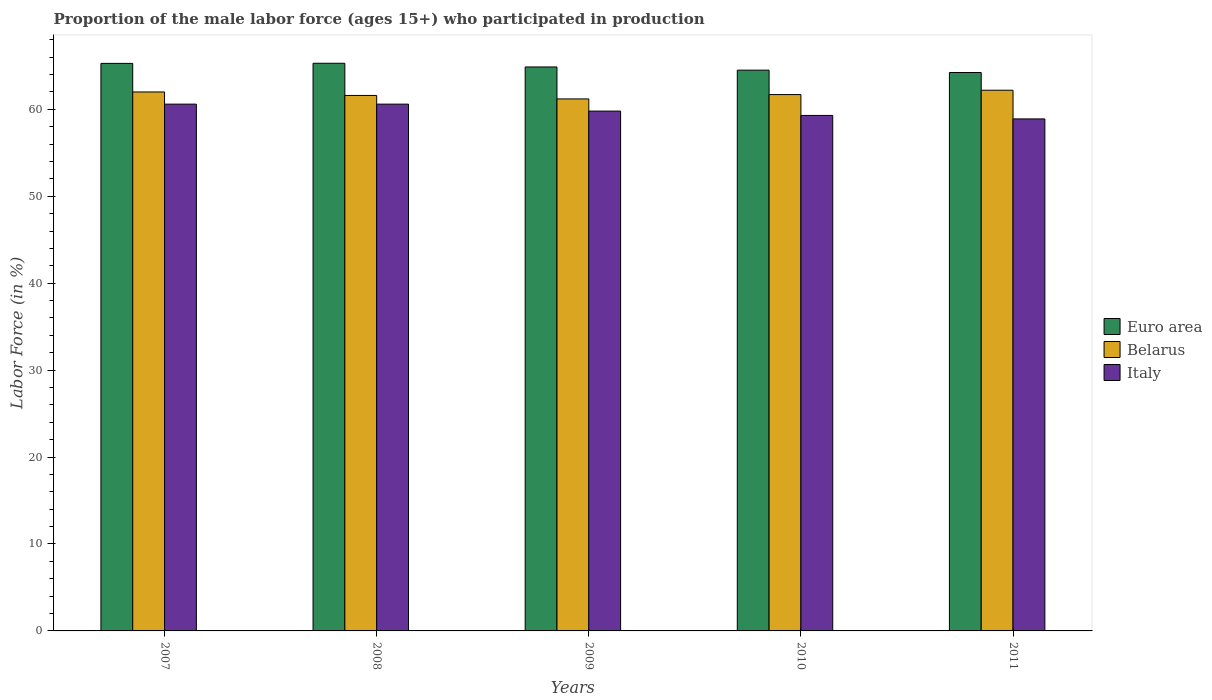How many different coloured bars are there?
Your response must be concise. 3. How many groups of bars are there?
Provide a succinct answer. 5. Are the number of bars per tick equal to the number of legend labels?
Keep it short and to the point. Yes. Are the number of bars on each tick of the X-axis equal?
Your answer should be very brief. Yes. How many bars are there on the 5th tick from the right?
Offer a very short reply. 3. What is the label of the 3rd group of bars from the left?
Provide a succinct answer. 2009. In how many cases, is the number of bars for a given year not equal to the number of legend labels?
Provide a short and direct response. 0. What is the proportion of the male labor force who participated in production in Euro area in 2011?
Offer a very short reply. 64.24. Across all years, what is the maximum proportion of the male labor force who participated in production in Euro area?
Provide a short and direct response. 65.3. Across all years, what is the minimum proportion of the male labor force who participated in production in Belarus?
Your answer should be compact. 61.2. In which year was the proportion of the male labor force who participated in production in Belarus minimum?
Make the answer very short. 2009. What is the total proportion of the male labor force who participated in production in Italy in the graph?
Offer a very short reply. 299.2. What is the difference between the proportion of the male labor force who participated in production in Italy in 2007 and that in 2009?
Keep it short and to the point. 0.8. What is the difference between the proportion of the male labor force who participated in production in Belarus in 2007 and the proportion of the male labor force who participated in production in Euro area in 2011?
Offer a very short reply. -2.24. What is the average proportion of the male labor force who participated in production in Belarus per year?
Your response must be concise. 61.74. In the year 2008, what is the difference between the proportion of the male labor force who participated in production in Euro area and proportion of the male labor force who participated in production in Belarus?
Offer a terse response. 3.7. In how many years, is the proportion of the male labor force who participated in production in Euro area greater than 58 %?
Provide a succinct answer. 5. What is the ratio of the proportion of the male labor force who participated in production in Euro area in 2008 to that in 2010?
Your response must be concise. 1.01. Is the proportion of the male labor force who participated in production in Belarus in 2009 less than that in 2011?
Provide a succinct answer. Yes. Is the difference between the proportion of the male labor force who participated in production in Euro area in 2008 and 2010 greater than the difference between the proportion of the male labor force who participated in production in Belarus in 2008 and 2010?
Give a very brief answer. Yes. What is the difference between the highest and the second highest proportion of the male labor force who participated in production in Euro area?
Offer a terse response. 0.01. In how many years, is the proportion of the male labor force who participated in production in Euro area greater than the average proportion of the male labor force who participated in production in Euro area taken over all years?
Offer a terse response. 3. Is the sum of the proportion of the male labor force who participated in production in Belarus in 2010 and 2011 greater than the maximum proportion of the male labor force who participated in production in Euro area across all years?
Offer a very short reply. Yes. What does the 1st bar from the right in 2007 represents?
Ensure brevity in your answer.  Italy. Is it the case that in every year, the sum of the proportion of the male labor force who participated in production in Italy and proportion of the male labor force who participated in production in Euro area is greater than the proportion of the male labor force who participated in production in Belarus?
Give a very brief answer. Yes. Are all the bars in the graph horizontal?
Your answer should be very brief. No. How many years are there in the graph?
Give a very brief answer. 5. What is the difference between two consecutive major ticks on the Y-axis?
Offer a very short reply. 10. Does the graph contain any zero values?
Your answer should be compact. No. How are the legend labels stacked?
Offer a very short reply. Vertical. What is the title of the graph?
Provide a short and direct response. Proportion of the male labor force (ages 15+) who participated in production. What is the Labor Force (in %) in Euro area in 2007?
Give a very brief answer. 65.29. What is the Labor Force (in %) of Belarus in 2007?
Ensure brevity in your answer.  62. What is the Labor Force (in %) in Italy in 2007?
Offer a very short reply. 60.6. What is the Labor Force (in %) in Euro area in 2008?
Your answer should be very brief. 65.3. What is the Labor Force (in %) of Belarus in 2008?
Give a very brief answer. 61.6. What is the Labor Force (in %) in Italy in 2008?
Your answer should be very brief. 60.6. What is the Labor Force (in %) of Euro area in 2009?
Provide a short and direct response. 64.88. What is the Labor Force (in %) of Belarus in 2009?
Your response must be concise. 61.2. What is the Labor Force (in %) of Italy in 2009?
Your answer should be very brief. 59.8. What is the Labor Force (in %) in Euro area in 2010?
Give a very brief answer. 64.51. What is the Labor Force (in %) in Belarus in 2010?
Offer a very short reply. 61.7. What is the Labor Force (in %) of Italy in 2010?
Provide a succinct answer. 59.3. What is the Labor Force (in %) in Euro area in 2011?
Ensure brevity in your answer.  64.24. What is the Labor Force (in %) in Belarus in 2011?
Offer a terse response. 62.2. What is the Labor Force (in %) of Italy in 2011?
Your response must be concise. 58.9. Across all years, what is the maximum Labor Force (in %) in Euro area?
Offer a terse response. 65.3. Across all years, what is the maximum Labor Force (in %) in Belarus?
Make the answer very short. 62.2. Across all years, what is the maximum Labor Force (in %) in Italy?
Keep it short and to the point. 60.6. Across all years, what is the minimum Labor Force (in %) in Euro area?
Provide a succinct answer. 64.24. Across all years, what is the minimum Labor Force (in %) in Belarus?
Keep it short and to the point. 61.2. Across all years, what is the minimum Labor Force (in %) of Italy?
Offer a very short reply. 58.9. What is the total Labor Force (in %) of Euro area in the graph?
Your answer should be compact. 324.22. What is the total Labor Force (in %) in Belarus in the graph?
Your answer should be very brief. 308.7. What is the total Labor Force (in %) in Italy in the graph?
Provide a succinct answer. 299.2. What is the difference between the Labor Force (in %) in Euro area in 2007 and that in 2008?
Offer a very short reply. -0.01. What is the difference between the Labor Force (in %) in Belarus in 2007 and that in 2008?
Make the answer very short. 0.4. What is the difference between the Labor Force (in %) in Italy in 2007 and that in 2008?
Offer a very short reply. 0. What is the difference between the Labor Force (in %) of Euro area in 2007 and that in 2009?
Give a very brief answer. 0.41. What is the difference between the Labor Force (in %) of Belarus in 2007 and that in 2009?
Offer a terse response. 0.8. What is the difference between the Labor Force (in %) in Italy in 2007 and that in 2009?
Make the answer very short. 0.8. What is the difference between the Labor Force (in %) in Euro area in 2007 and that in 2010?
Provide a succinct answer. 0.78. What is the difference between the Labor Force (in %) of Italy in 2007 and that in 2010?
Provide a succinct answer. 1.3. What is the difference between the Labor Force (in %) of Euro area in 2007 and that in 2011?
Give a very brief answer. 1.05. What is the difference between the Labor Force (in %) of Italy in 2007 and that in 2011?
Your response must be concise. 1.7. What is the difference between the Labor Force (in %) of Euro area in 2008 and that in 2009?
Your answer should be compact. 0.43. What is the difference between the Labor Force (in %) of Belarus in 2008 and that in 2009?
Provide a short and direct response. 0.4. What is the difference between the Labor Force (in %) of Italy in 2008 and that in 2009?
Ensure brevity in your answer.  0.8. What is the difference between the Labor Force (in %) in Euro area in 2008 and that in 2010?
Offer a terse response. 0.79. What is the difference between the Labor Force (in %) of Belarus in 2008 and that in 2010?
Ensure brevity in your answer.  -0.1. What is the difference between the Labor Force (in %) in Euro area in 2008 and that in 2011?
Offer a terse response. 1.07. What is the difference between the Labor Force (in %) in Belarus in 2008 and that in 2011?
Provide a short and direct response. -0.6. What is the difference between the Labor Force (in %) in Euro area in 2009 and that in 2010?
Your answer should be compact. 0.37. What is the difference between the Labor Force (in %) in Euro area in 2009 and that in 2011?
Your response must be concise. 0.64. What is the difference between the Labor Force (in %) of Euro area in 2010 and that in 2011?
Your response must be concise. 0.27. What is the difference between the Labor Force (in %) of Belarus in 2010 and that in 2011?
Make the answer very short. -0.5. What is the difference between the Labor Force (in %) in Italy in 2010 and that in 2011?
Provide a succinct answer. 0.4. What is the difference between the Labor Force (in %) of Euro area in 2007 and the Labor Force (in %) of Belarus in 2008?
Make the answer very short. 3.69. What is the difference between the Labor Force (in %) of Euro area in 2007 and the Labor Force (in %) of Italy in 2008?
Offer a very short reply. 4.69. What is the difference between the Labor Force (in %) in Belarus in 2007 and the Labor Force (in %) in Italy in 2008?
Offer a terse response. 1.4. What is the difference between the Labor Force (in %) in Euro area in 2007 and the Labor Force (in %) in Belarus in 2009?
Your answer should be compact. 4.09. What is the difference between the Labor Force (in %) in Euro area in 2007 and the Labor Force (in %) in Italy in 2009?
Provide a succinct answer. 5.49. What is the difference between the Labor Force (in %) of Belarus in 2007 and the Labor Force (in %) of Italy in 2009?
Your answer should be compact. 2.2. What is the difference between the Labor Force (in %) of Euro area in 2007 and the Labor Force (in %) of Belarus in 2010?
Provide a succinct answer. 3.59. What is the difference between the Labor Force (in %) of Euro area in 2007 and the Labor Force (in %) of Italy in 2010?
Your response must be concise. 5.99. What is the difference between the Labor Force (in %) of Euro area in 2007 and the Labor Force (in %) of Belarus in 2011?
Offer a very short reply. 3.09. What is the difference between the Labor Force (in %) of Euro area in 2007 and the Labor Force (in %) of Italy in 2011?
Ensure brevity in your answer.  6.39. What is the difference between the Labor Force (in %) in Euro area in 2008 and the Labor Force (in %) in Belarus in 2009?
Keep it short and to the point. 4.1. What is the difference between the Labor Force (in %) of Euro area in 2008 and the Labor Force (in %) of Italy in 2009?
Offer a very short reply. 5.5. What is the difference between the Labor Force (in %) of Euro area in 2008 and the Labor Force (in %) of Belarus in 2010?
Make the answer very short. 3.6. What is the difference between the Labor Force (in %) in Euro area in 2008 and the Labor Force (in %) in Italy in 2010?
Give a very brief answer. 6. What is the difference between the Labor Force (in %) of Belarus in 2008 and the Labor Force (in %) of Italy in 2010?
Offer a very short reply. 2.3. What is the difference between the Labor Force (in %) of Euro area in 2008 and the Labor Force (in %) of Belarus in 2011?
Ensure brevity in your answer.  3.1. What is the difference between the Labor Force (in %) in Euro area in 2008 and the Labor Force (in %) in Italy in 2011?
Your answer should be compact. 6.4. What is the difference between the Labor Force (in %) of Belarus in 2008 and the Labor Force (in %) of Italy in 2011?
Your answer should be compact. 2.7. What is the difference between the Labor Force (in %) in Euro area in 2009 and the Labor Force (in %) in Belarus in 2010?
Keep it short and to the point. 3.18. What is the difference between the Labor Force (in %) of Euro area in 2009 and the Labor Force (in %) of Italy in 2010?
Your answer should be compact. 5.58. What is the difference between the Labor Force (in %) in Euro area in 2009 and the Labor Force (in %) in Belarus in 2011?
Your answer should be compact. 2.68. What is the difference between the Labor Force (in %) in Euro area in 2009 and the Labor Force (in %) in Italy in 2011?
Give a very brief answer. 5.98. What is the difference between the Labor Force (in %) of Belarus in 2009 and the Labor Force (in %) of Italy in 2011?
Make the answer very short. 2.3. What is the difference between the Labor Force (in %) in Euro area in 2010 and the Labor Force (in %) in Belarus in 2011?
Your answer should be very brief. 2.31. What is the difference between the Labor Force (in %) of Euro area in 2010 and the Labor Force (in %) of Italy in 2011?
Give a very brief answer. 5.61. What is the average Labor Force (in %) of Euro area per year?
Give a very brief answer. 64.84. What is the average Labor Force (in %) of Belarus per year?
Provide a succinct answer. 61.74. What is the average Labor Force (in %) in Italy per year?
Provide a succinct answer. 59.84. In the year 2007, what is the difference between the Labor Force (in %) of Euro area and Labor Force (in %) of Belarus?
Keep it short and to the point. 3.29. In the year 2007, what is the difference between the Labor Force (in %) in Euro area and Labor Force (in %) in Italy?
Make the answer very short. 4.69. In the year 2007, what is the difference between the Labor Force (in %) in Belarus and Labor Force (in %) in Italy?
Make the answer very short. 1.4. In the year 2008, what is the difference between the Labor Force (in %) of Euro area and Labor Force (in %) of Belarus?
Offer a very short reply. 3.7. In the year 2008, what is the difference between the Labor Force (in %) in Euro area and Labor Force (in %) in Italy?
Ensure brevity in your answer.  4.7. In the year 2008, what is the difference between the Labor Force (in %) in Belarus and Labor Force (in %) in Italy?
Your answer should be compact. 1. In the year 2009, what is the difference between the Labor Force (in %) in Euro area and Labor Force (in %) in Belarus?
Keep it short and to the point. 3.68. In the year 2009, what is the difference between the Labor Force (in %) of Euro area and Labor Force (in %) of Italy?
Provide a succinct answer. 5.08. In the year 2009, what is the difference between the Labor Force (in %) of Belarus and Labor Force (in %) of Italy?
Provide a short and direct response. 1.4. In the year 2010, what is the difference between the Labor Force (in %) in Euro area and Labor Force (in %) in Belarus?
Offer a very short reply. 2.81. In the year 2010, what is the difference between the Labor Force (in %) in Euro area and Labor Force (in %) in Italy?
Ensure brevity in your answer.  5.21. In the year 2010, what is the difference between the Labor Force (in %) of Belarus and Labor Force (in %) of Italy?
Give a very brief answer. 2.4. In the year 2011, what is the difference between the Labor Force (in %) of Euro area and Labor Force (in %) of Belarus?
Provide a succinct answer. 2.04. In the year 2011, what is the difference between the Labor Force (in %) in Euro area and Labor Force (in %) in Italy?
Offer a very short reply. 5.34. What is the ratio of the Labor Force (in %) of Euro area in 2007 to that in 2008?
Make the answer very short. 1. What is the ratio of the Labor Force (in %) in Italy in 2007 to that in 2008?
Give a very brief answer. 1. What is the ratio of the Labor Force (in %) in Belarus in 2007 to that in 2009?
Offer a terse response. 1.01. What is the ratio of the Labor Force (in %) in Italy in 2007 to that in 2009?
Provide a short and direct response. 1.01. What is the ratio of the Labor Force (in %) in Euro area in 2007 to that in 2010?
Your answer should be very brief. 1.01. What is the ratio of the Labor Force (in %) of Italy in 2007 to that in 2010?
Ensure brevity in your answer.  1.02. What is the ratio of the Labor Force (in %) of Euro area in 2007 to that in 2011?
Keep it short and to the point. 1.02. What is the ratio of the Labor Force (in %) in Belarus in 2007 to that in 2011?
Make the answer very short. 1. What is the ratio of the Labor Force (in %) of Italy in 2007 to that in 2011?
Provide a succinct answer. 1.03. What is the ratio of the Labor Force (in %) in Euro area in 2008 to that in 2009?
Your answer should be very brief. 1.01. What is the ratio of the Labor Force (in %) in Italy in 2008 to that in 2009?
Provide a succinct answer. 1.01. What is the ratio of the Labor Force (in %) of Euro area in 2008 to that in 2010?
Offer a terse response. 1.01. What is the ratio of the Labor Force (in %) in Italy in 2008 to that in 2010?
Give a very brief answer. 1.02. What is the ratio of the Labor Force (in %) in Euro area in 2008 to that in 2011?
Make the answer very short. 1.02. What is the ratio of the Labor Force (in %) in Italy in 2008 to that in 2011?
Provide a succinct answer. 1.03. What is the ratio of the Labor Force (in %) in Belarus in 2009 to that in 2010?
Give a very brief answer. 0.99. What is the ratio of the Labor Force (in %) in Italy in 2009 to that in 2010?
Provide a short and direct response. 1.01. What is the ratio of the Labor Force (in %) of Belarus in 2009 to that in 2011?
Offer a terse response. 0.98. What is the ratio of the Labor Force (in %) of Italy in 2009 to that in 2011?
Your answer should be very brief. 1.02. What is the ratio of the Labor Force (in %) in Euro area in 2010 to that in 2011?
Keep it short and to the point. 1. What is the ratio of the Labor Force (in %) of Belarus in 2010 to that in 2011?
Provide a short and direct response. 0.99. What is the ratio of the Labor Force (in %) of Italy in 2010 to that in 2011?
Ensure brevity in your answer.  1.01. What is the difference between the highest and the second highest Labor Force (in %) of Euro area?
Your answer should be compact. 0.01. What is the difference between the highest and the second highest Labor Force (in %) of Belarus?
Provide a short and direct response. 0.2. What is the difference between the highest and the lowest Labor Force (in %) in Euro area?
Make the answer very short. 1.07. What is the difference between the highest and the lowest Labor Force (in %) of Belarus?
Ensure brevity in your answer.  1. What is the difference between the highest and the lowest Labor Force (in %) of Italy?
Your answer should be very brief. 1.7. 